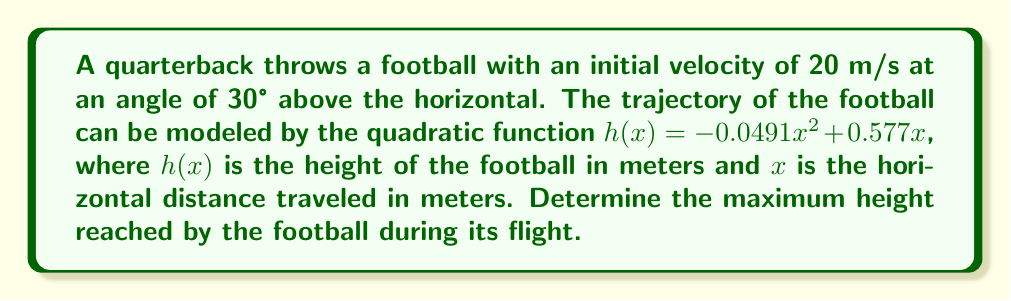Could you help me with this problem? To find the maximum height of the parabolic trajectory, we need to follow these steps:

1) The general form of a quadratic function is $f(x) = ax^2 + bx + c$, where the vertex form is $f(x) = a(x-h)^2 + k$. Here, $(h,k)$ is the vertex of the parabola.

2) In our case, $h(x) = -0.0491x^2 + 0.577x$, so $a = -0.0491$, $b = 0.577$, and $c = 0$.

3) To find the x-coordinate of the vertex, we use the formula $x = -\frac{b}{2a}$:

   $x = -\frac{0.577}{2(-0.0491)} = \frac{0.577}{0.0982} = 5.877$ meters

4) To find the y-coordinate (maximum height), we substitute this x-value back into the original function:

   $h(5.877) = -0.0491(5.877)^2 + 0.577(5.877)$
              $= -0.0491(34.539) + 3.391$
              $= -1.696 + 3.391$
              $= 1.695$ meters

5) Therefore, the maximum height reached by the football is approximately 1.695 meters.
Answer: 1.695 meters 